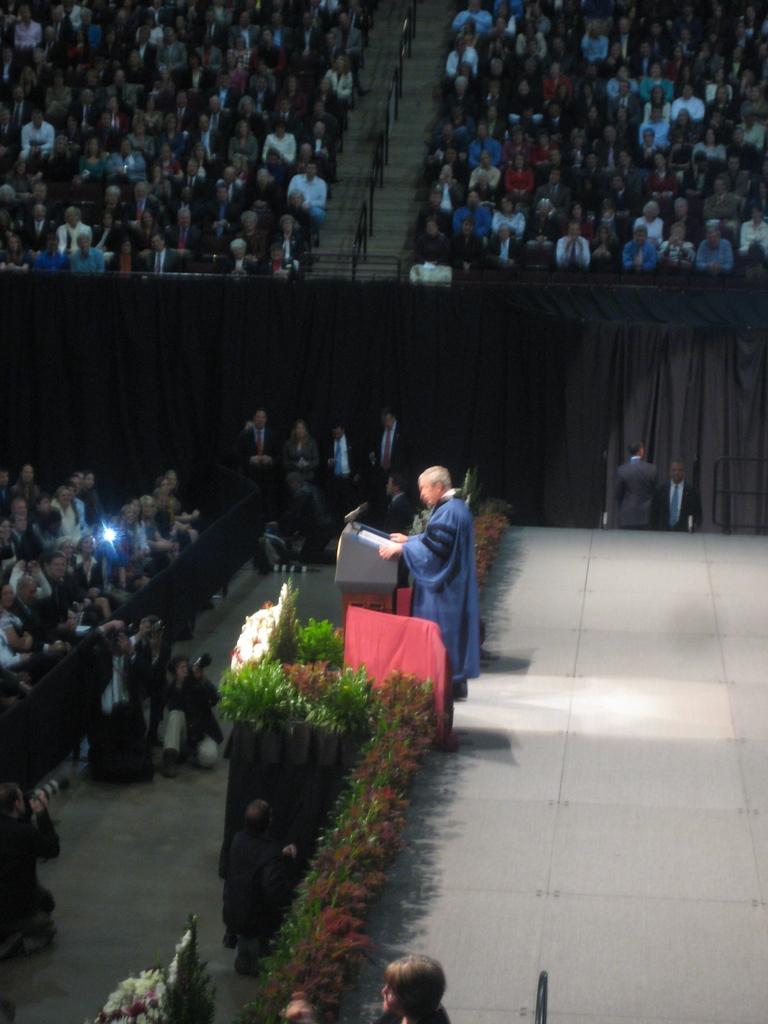Describe this image in one or two sentences. In the middle, we see the man is standing on the stage. In front of him, we see a podium on which a microphone and the papers are placed. Beside him, we see the flower pots. On the left side, we see the people are sitting on the chairs. Beside them, we see three men are clicking photos with the camera. In the middle, we see the people are standing. Behind them, we see the curtains in grey and black color. At the top, we see the staircase and the people are sitting on the chairs. 